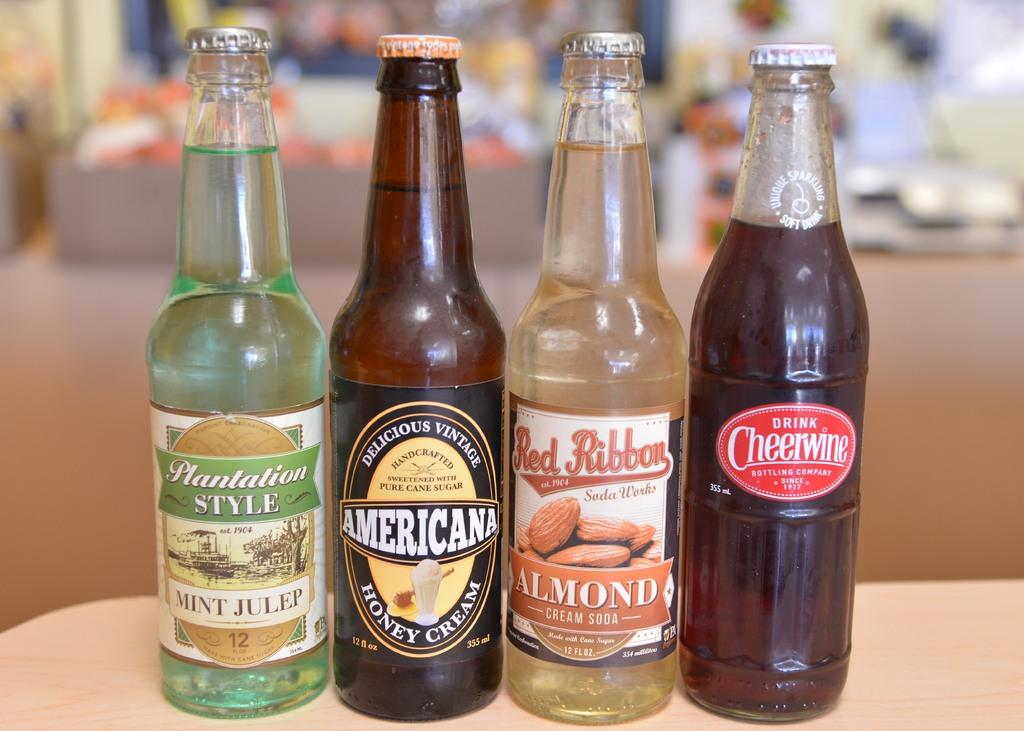<image>
Render a clear and concise summary of the photo. Four bottles of soda are on a table and labeled Mint Julep, Honey Cream, Almond, and Black Cheerwine. 